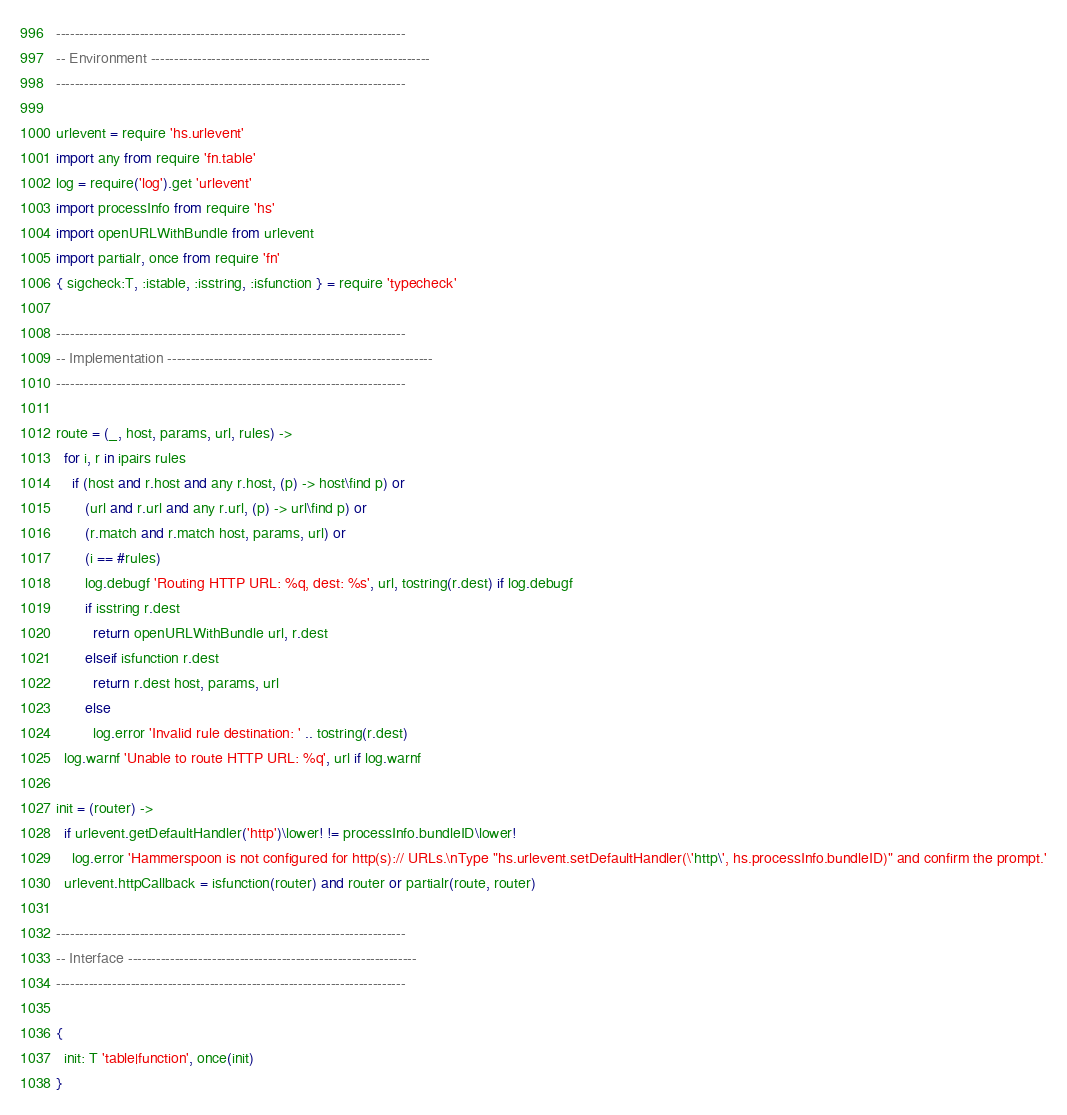<code> <loc_0><loc_0><loc_500><loc_500><_MoonScript_>---------------------------------------------------------------------------
-- Environment ------------------------------------------------------------
---------------------------------------------------------------------------

urlevent = require 'hs.urlevent'
import any from require 'fn.table'
log = require('log').get 'urlevent'
import processInfo from require 'hs'
import openURLWithBundle from urlevent
import partialr, once from require 'fn'
{ sigcheck:T, :istable, :isstring, :isfunction } = require 'typecheck'

---------------------------------------------------------------------------
-- Implementation ---------------------------------------------------------
---------------------------------------------------------------------------

route = (_, host, params, url, rules) ->
  for i, r in ipairs rules
    if (host and r.host and any r.host, (p) -> host\find p) or
       (url and r.url and any r.url, (p) -> url\find p) or
       (r.match and r.match host, params, url) or
       (i == #rules)
       log.debugf 'Routing HTTP URL: %q, dest: %s', url, tostring(r.dest) if log.debugf
       if isstring r.dest
         return openURLWithBundle url, r.dest
       elseif isfunction r.dest
         return r.dest host, params, url
       else
         log.error 'Invalid rule destination: ' .. tostring(r.dest)
  log.warnf 'Unable to route HTTP URL: %q', url if log.warnf

init = (router) ->
  if urlevent.getDefaultHandler('http')\lower! != processInfo.bundleID\lower!
    log.error 'Hammerspoon is not configured for http(s):// URLs.\nType "hs.urlevent.setDefaultHandler(\'http\', hs.processInfo.bundleID)" and confirm the prompt.'
  urlevent.httpCallback = isfunction(router) and router or partialr(route, router)

---------------------------------------------------------------------------
-- Interface --------------------------------------------------------------
---------------------------------------------------------------------------

{
  init: T 'table|function', once(init)
}
</code> 